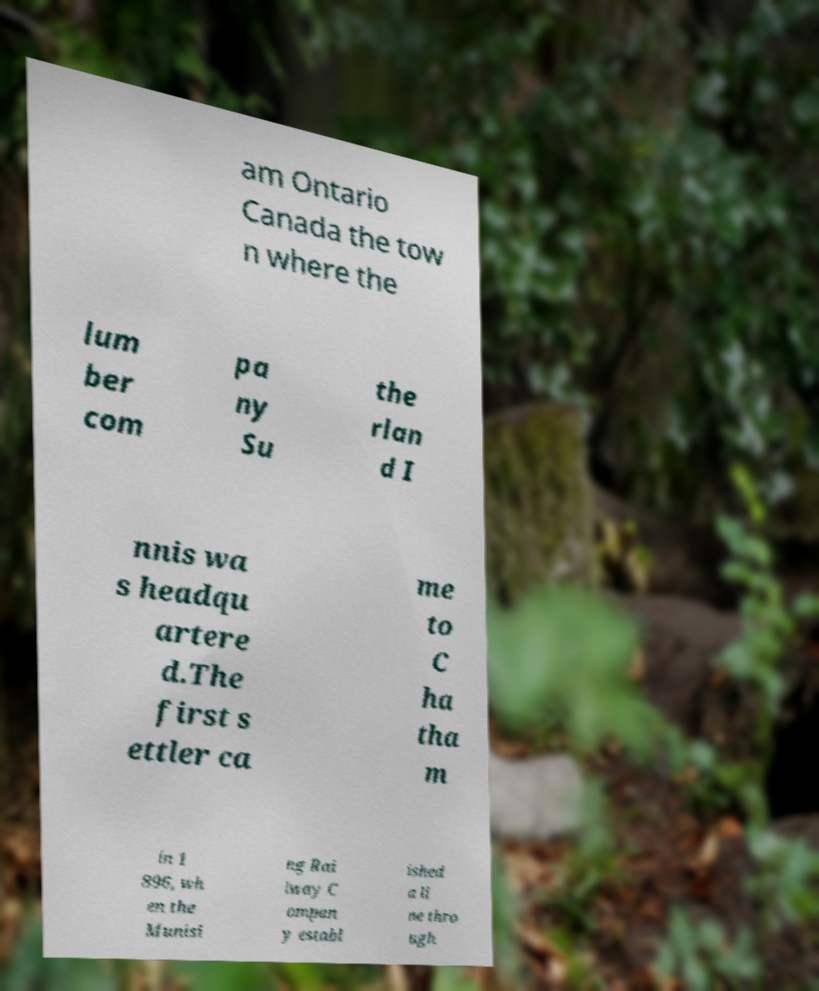Could you extract and type out the text from this image? am Ontario Canada the tow n where the lum ber com pa ny Su the rlan d I nnis wa s headqu artere d.The first s ettler ca me to C ha tha m in 1 896, wh en the Munisi ng Rai lway C ompan y establ ished a li ne thro ugh 